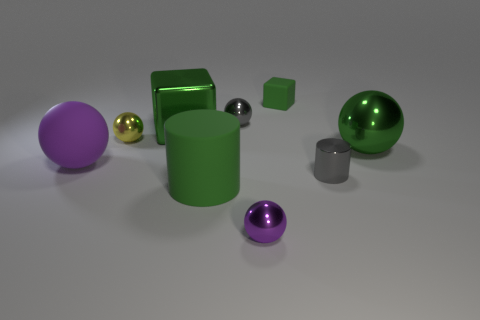What number of other objects are the same color as the tiny rubber object? A total of 3 objects share the same color as the miniature rubber item, which stands out with a distinctive and vibrant hue. 